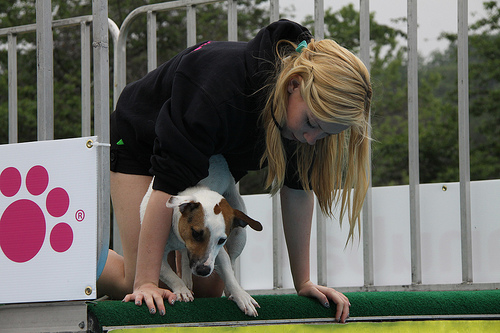<image>
Is the dog under the girl? Yes. The dog is positioned underneath the girl, with the girl above it in the vertical space. Is the fence behind the dog? Yes. From this viewpoint, the fence is positioned behind the dog, with the dog partially or fully occluding the fence. 